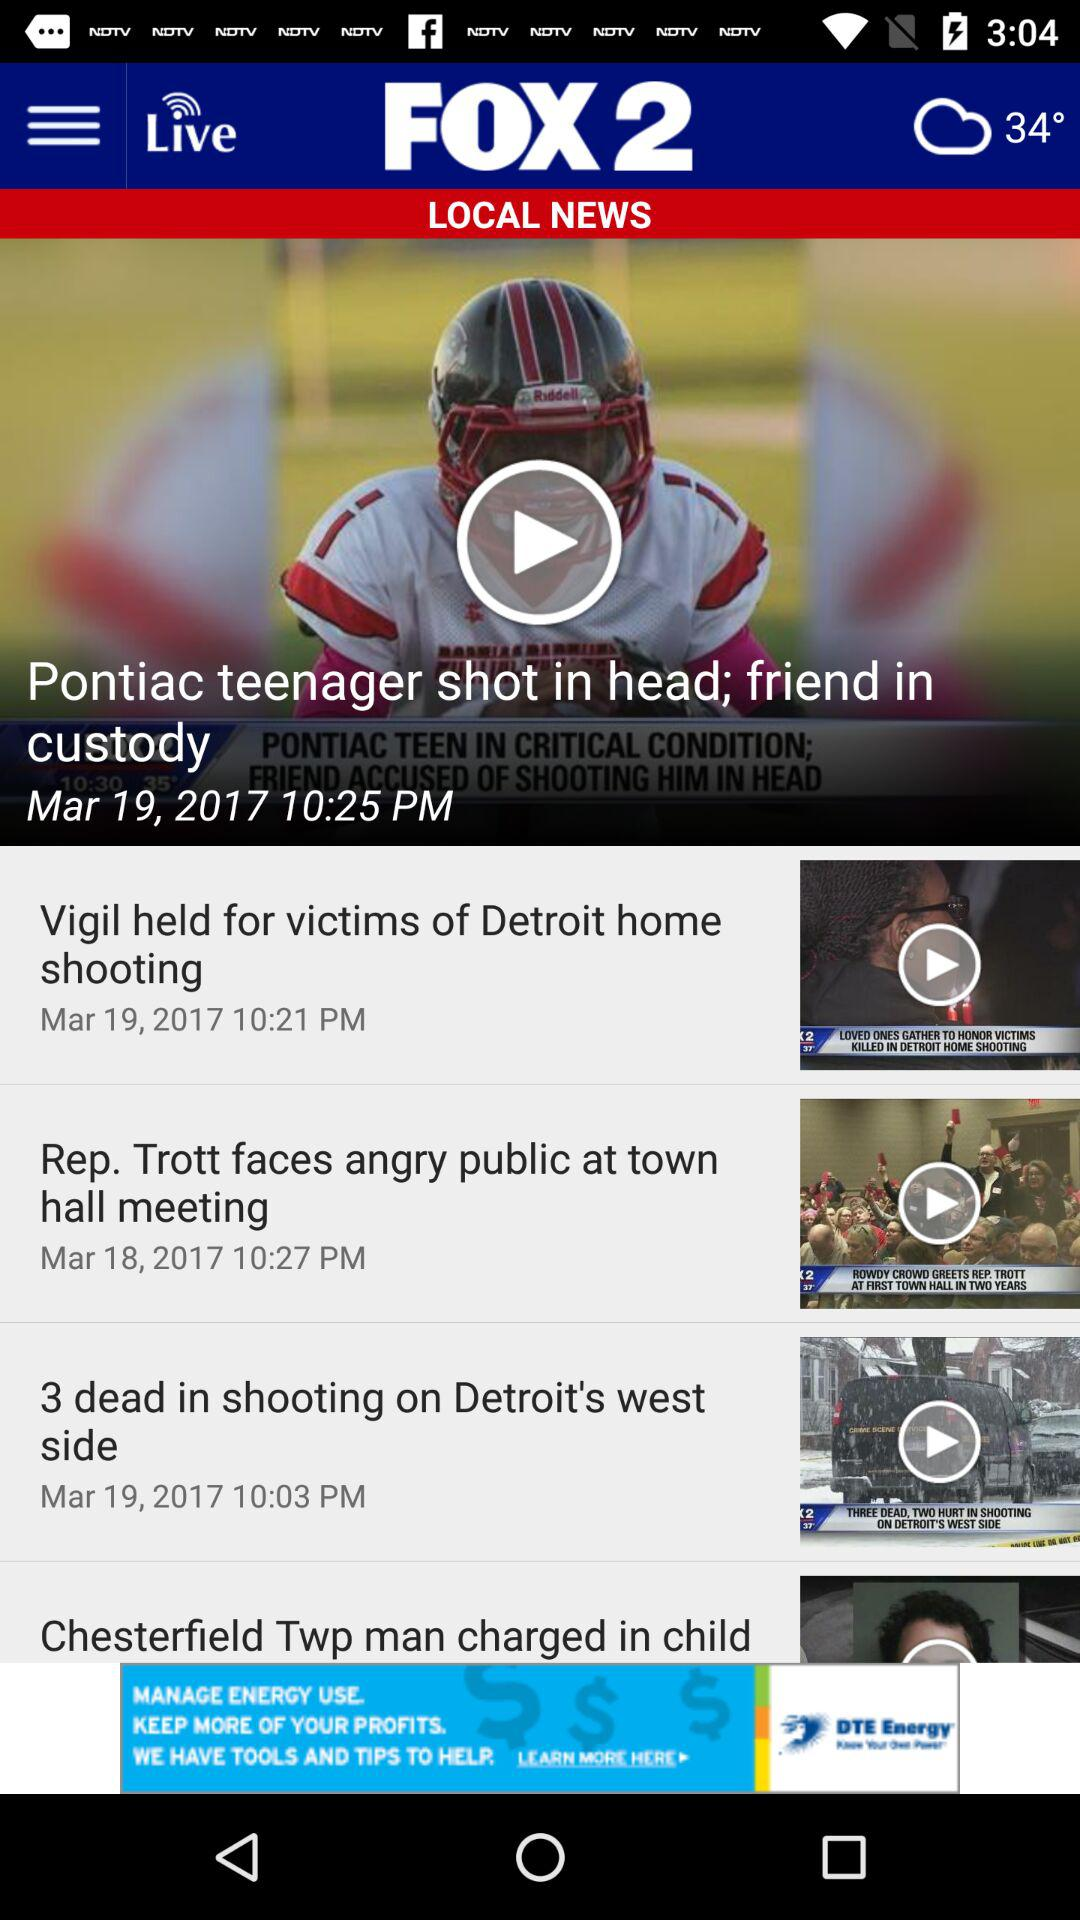What is the temperature? The temperature is 34°. 